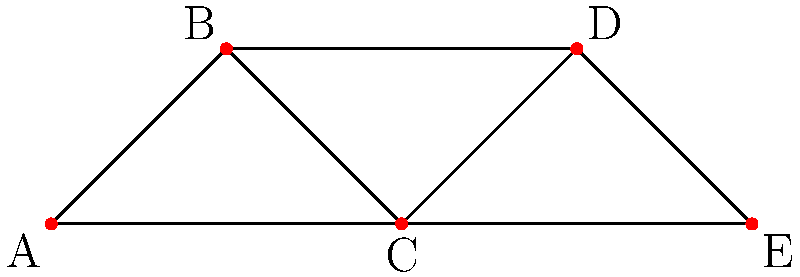In the safety equipment distribution network for a professional sports league shown above, each node represents a distribution center, and each edge represents a direct connection for equipment transfer. If node C becomes inaccessible due to a natural disaster, what is the minimum number of edges that need to be added to ensure that all remaining nodes are still connected, maintaining the network's resilience? To solve this problem, we need to follow these steps:

1. Understand the current network structure:
   - The network has 5 nodes (A, B, C, D, E) connected by edges.
   - Node C is connected to all other nodes (A, B, D, E).

2. Remove node C and its connections:
   - After removal, we have two disconnected components:
     Component 1: A-B
     Component 2: D-E

3. Determine the minimum number of edges needed to reconnect the network:
   - We need to connect these two components with at least one edge.
   - The minimum number of edges required to connect two disconnected components is always 1.

4. Verify the solution:
   - Adding one edge between any node in Component 1 (A or B) and any node in Component 2 (D or E) will reconnect the network.
   - For example, adding an edge between B and D would suffice.

5. Consider network resilience:
   - Adding just one edge would make the network vulnerable to future disruptions.
   - However, the question asks for the minimum number of edges, so we stick to one.

Therefore, the minimum number of edges that need to be added to ensure all remaining nodes are connected after removing node C is 1.
Answer: 1 edge 